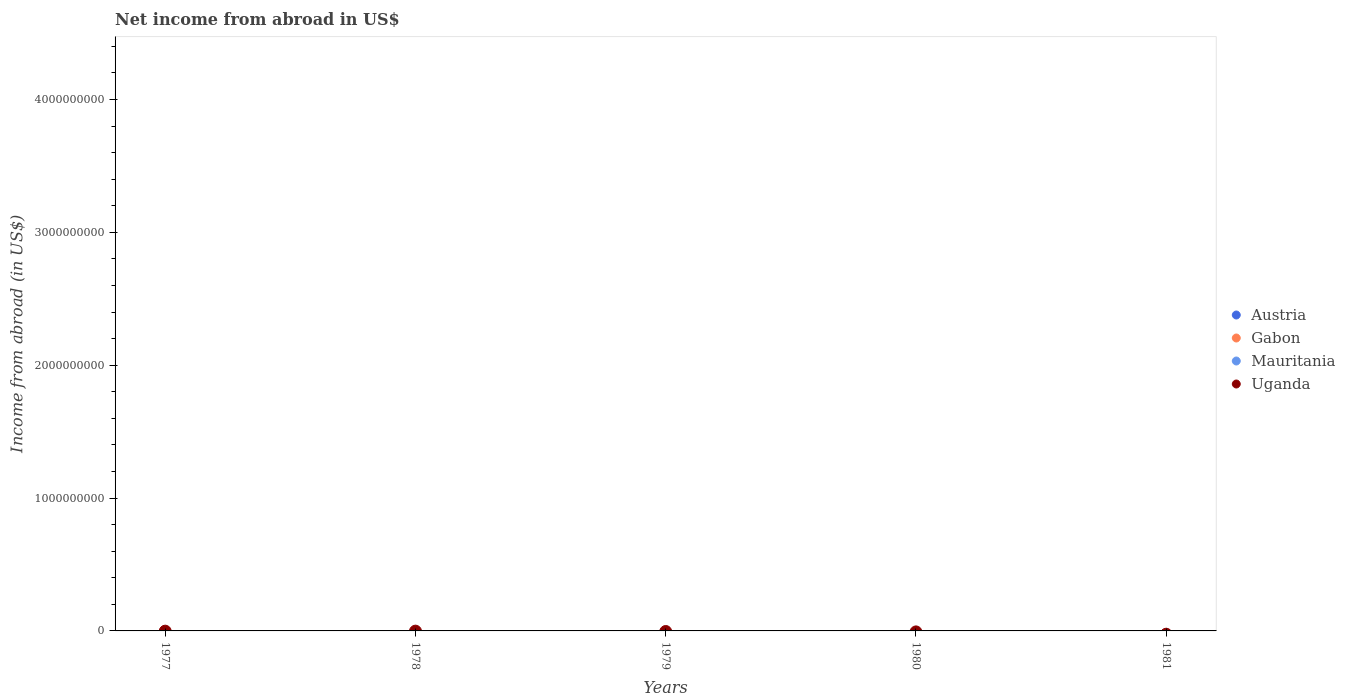How many different coloured dotlines are there?
Your response must be concise. 0. Is the number of dotlines equal to the number of legend labels?
Your answer should be compact. No. Across all years, what is the minimum net income from abroad in Gabon?
Provide a succinct answer. 0. What is the total net income from abroad in Gabon in the graph?
Keep it short and to the point. 0. What is the difference between the net income from abroad in Mauritania in 1981 and the net income from abroad in Uganda in 1977?
Your response must be concise. 0. What is the average net income from abroad in Mauritania per year?
Provide a short and direct response. 0. In how many years, is the net income from abroad in Uganda greater than 2000000000 US$?
Offer a terse response. 0. Is it the case that in every year, the sum of the net income from abroad in Austria and net income from abroad in Mauritania  is greater than the net income from abroad in Uganda?
Offer a terse response. No. Does the net income from abroad in Gabon monotonically increase over the years?
Provide a short and direct response. No. What is the difference between two consecutive major ticks on the Y-axis?
Ensure brevity in your answer.  1.00e+09. Are the values on the major ticks of Y-axis written in scientific E-notation?
Provide a short and direct response. No. Does the graph contain any zero values?
Keep it short and to the point. Yes. Does the graph contain grids?
Offer a terse response. No. What is the title of the graph?
Give a very brief answer. Net income from abroad in US$. Does "High income: nonOECD" appear as one of the legend labels in the graph?
Make the answer very short. No. What is the label or title of the X-axis?
Offer a terse response. Years. What is the label or title of the Y-axis?
Your response must be concise. Income from abroad (in US$). What is the Income from abroad (in US$) in Austria in 1977?
Provide a short and direct response. 0. What is the Income from abroad (in US$) of Gabon in 1977?
Provide a succinct answer. 0. What is the Income from abroad (in US$) of Mauritania in 1977?
Your answer should be very brief. 0. What is the Income from abroad (in US$) in Austria in 1981?
Ensure brevity in your answer.  0. What is the total Income from abroad (in US$) of Mauritania in the graph?
Your response must be concise. 0. What is the total Income from abroad (in US$) of Uganda in the graph?
Your answer should be very brief. 0. What is the average Income from abroad (in US$) in Austria per year?
Your response must be concise. 0. What is the average Income from abroad (in US$) in Gabon per year?
Give a very brief answer. 0. What is the average Income from abroad (in US$) in Mauritania per year?
Provide a succinct answer. 0. What is the average Income from abroad (in US$) of Uganda per year?
Provide a succinct answer. 0. 